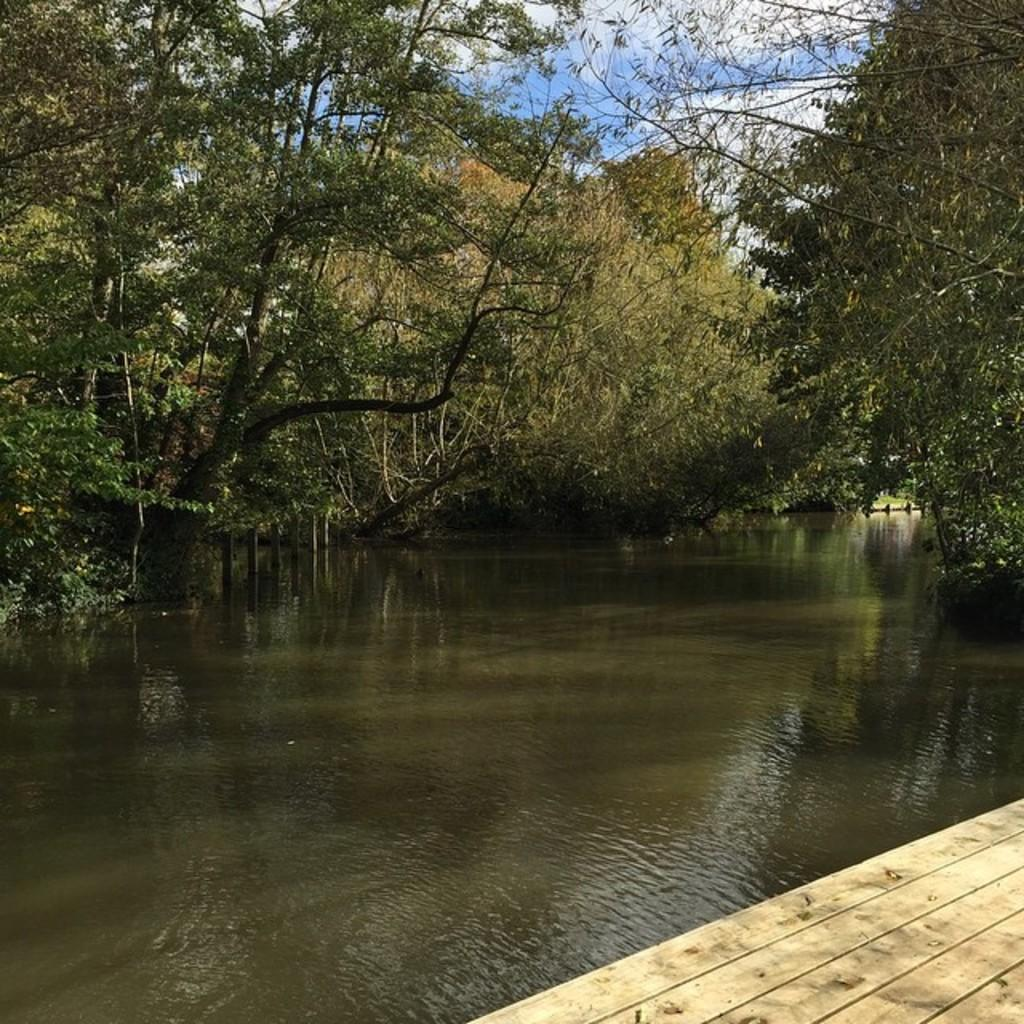What is present in the image that is liquid? There is water in the image. What type of vegetation can be seen in the background of the image? There are trees in the background of the image. What is the color of the trees in the image? The trees are green in color. What is visible above the trees in the image? The sky is visible in the image. What colors can be seen in the sky in the image? The sky has both white and blue colors. Can you see a scarf floating on the water in the image? There is no scarf present in the image. Is there a lake visible in the image? The image does not show a lake; it only shows water. 